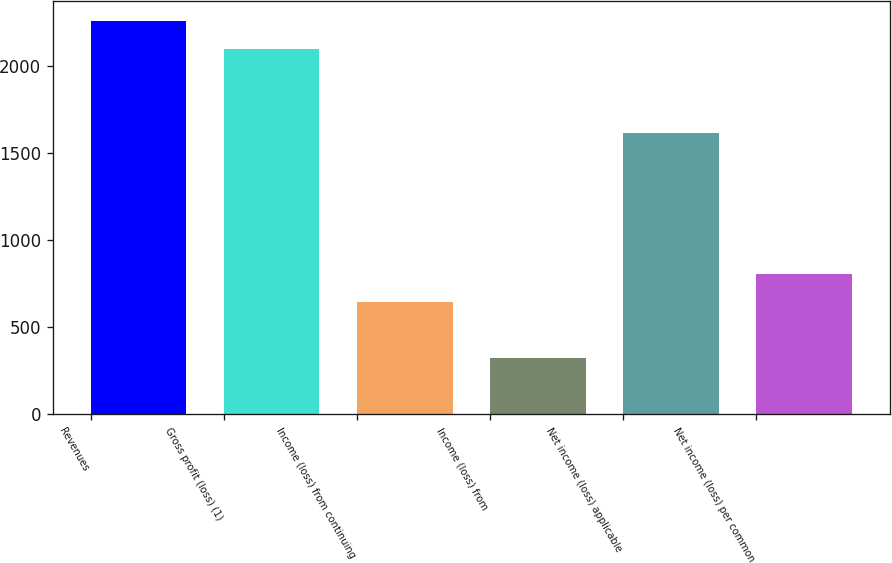Convert chart to OTSL. <chart><loc_0><loc_0><loc_500><loc_500><bar_chart><fcel>Revenues<fcel>Gross profit (loss) (1)<fcel>Income (loss) from continuing<fcel>Income (loss) from<fcel>Net income (loss) applicable<fcel>Net income (loss) per common<nl><fcel>2262.36<fcel>2100.77<fcel>646.46<fcel>323.28<fcel>1616<fcel>808.05<nl></chart> 